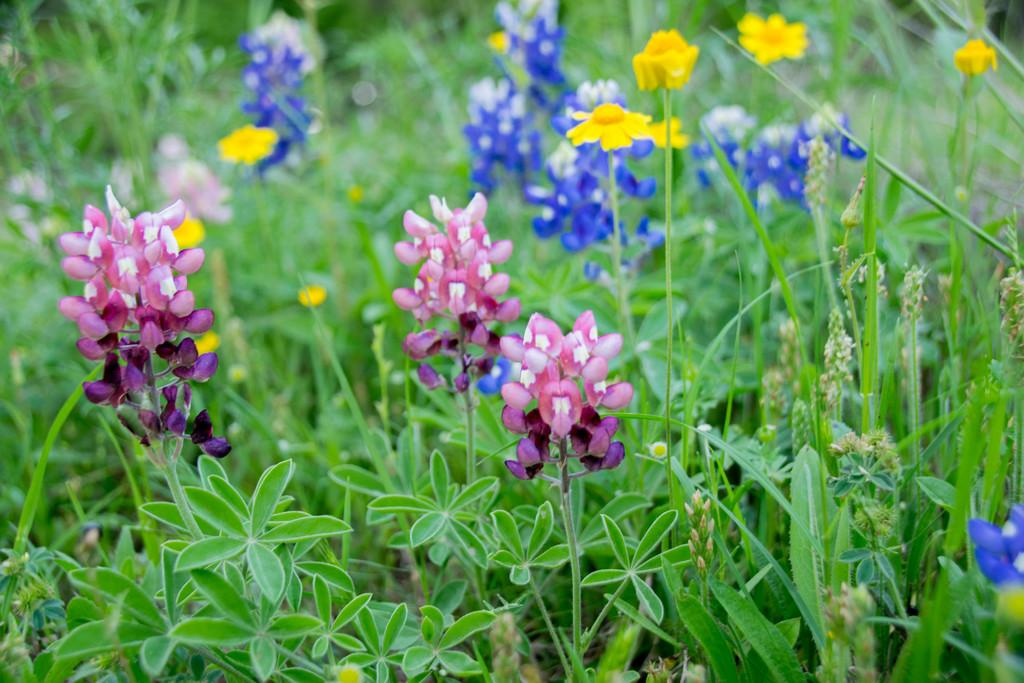What type of living organisms can be seen in the image? Plants and flowers are visible in the image. What colors are present on the flowers in the image? The flowers have pink, yellow, and blue colors. What type of animal can be seen interacting with the flowers in the image? There is no animal present in the image; it only features plants and flowers. 